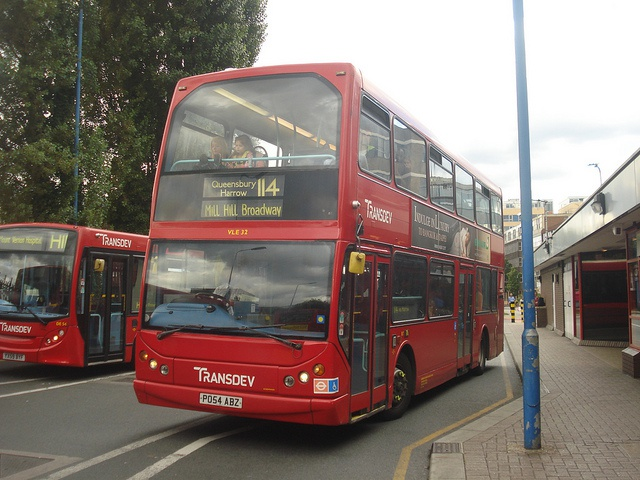Describe the objects in this image and their specific colors. I can see bus in black, gray, darkgray, and brown tones, bus in black, brown, gray, and maroon tones, people in black and gray tones, people in black, darkgray, and gray tones, and people in black, gray, and darkgray tones in this image. 